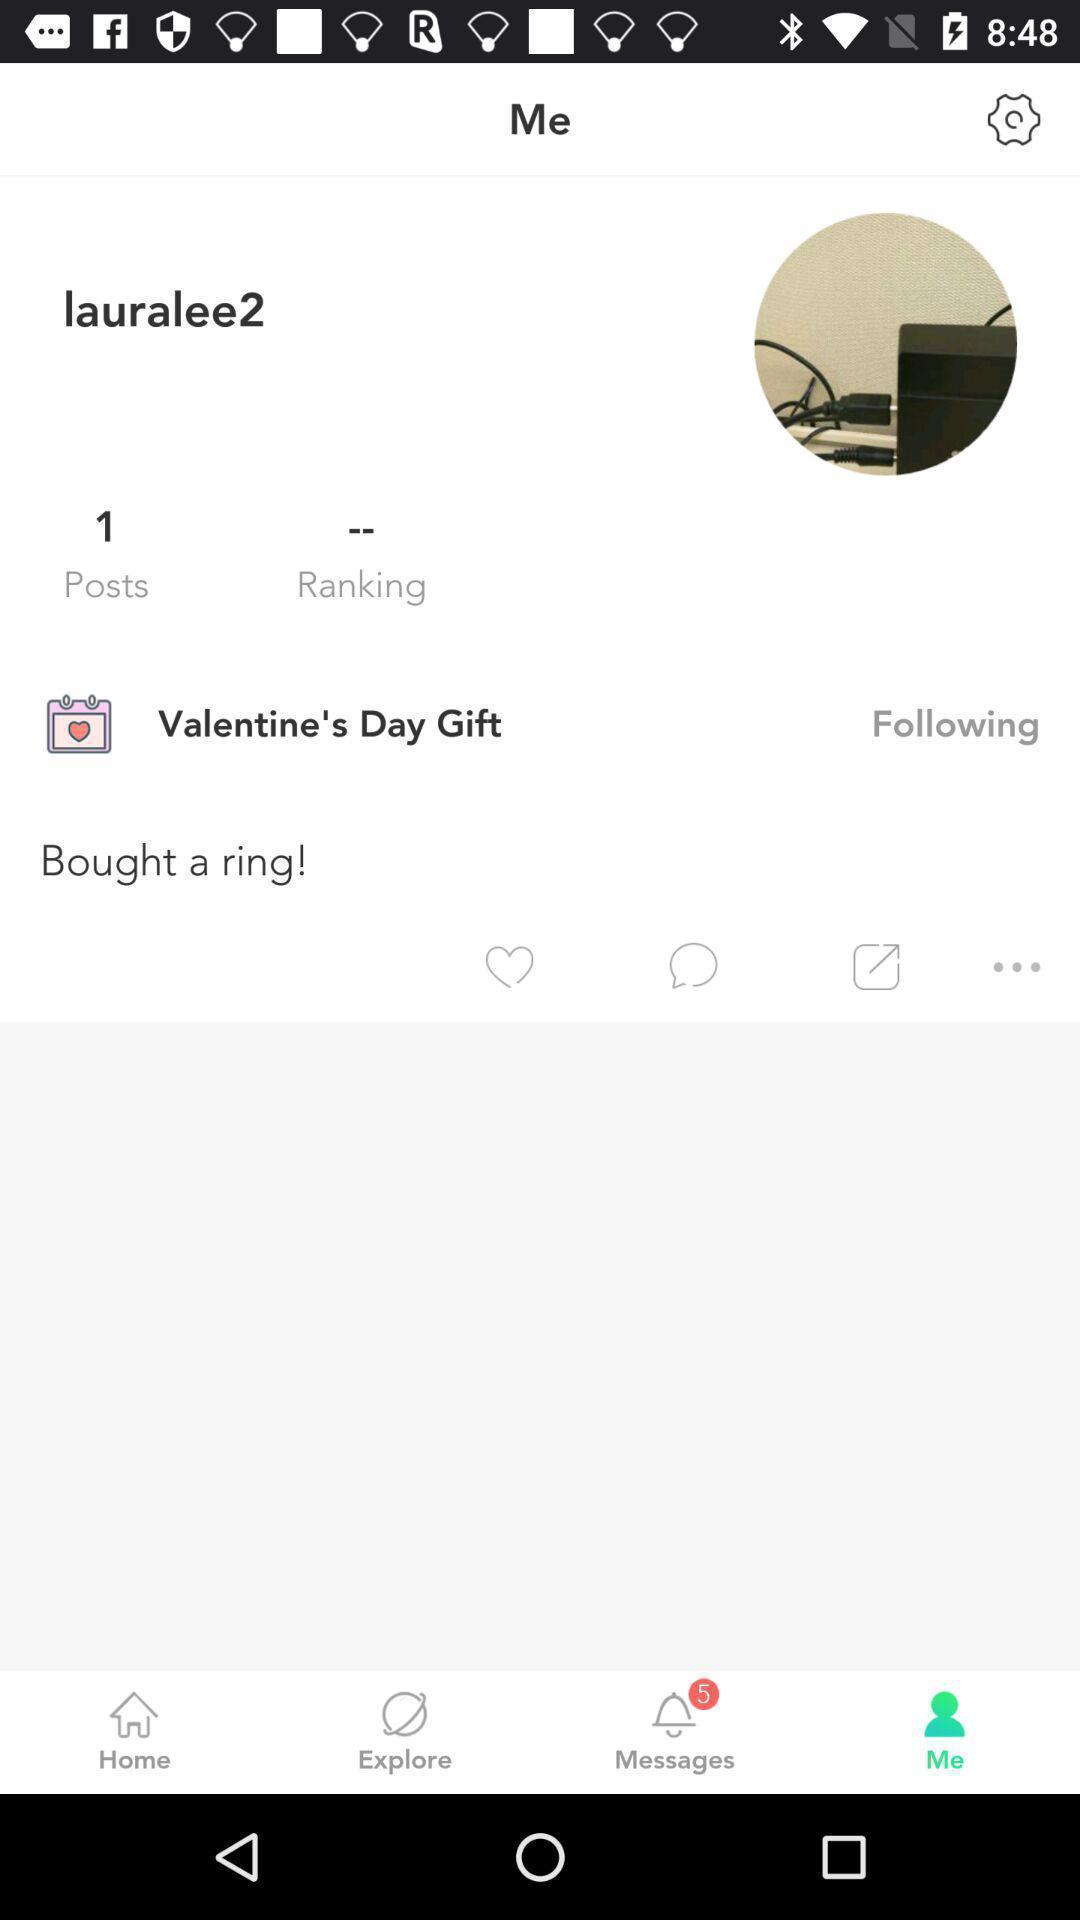Tell me about the visual elements in this screen capture. Screen page displaying a profile in social app. 